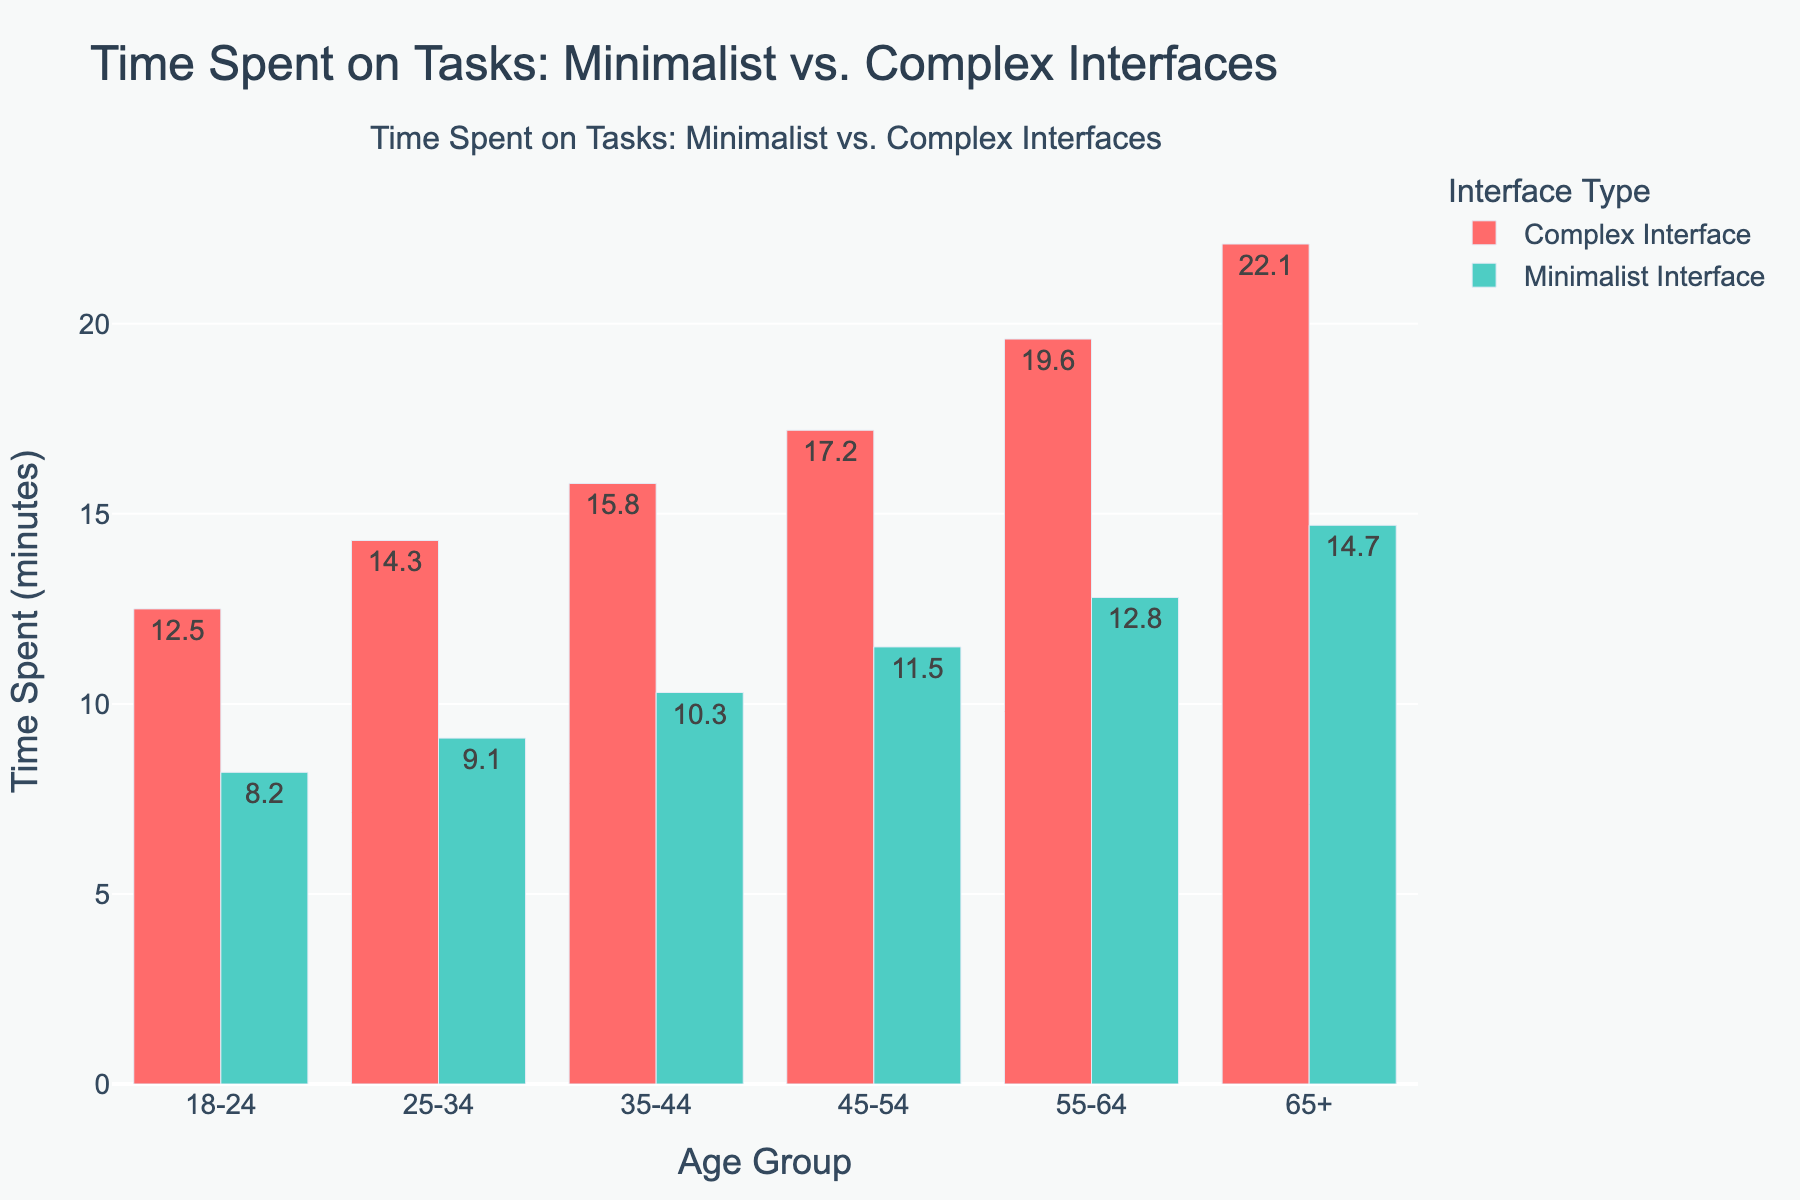What's the difference in time spent on tasks between the 25-34 age group using minimalist and complex interfaces? The time spent on tasks for the 25-34 age group using the minimalist interface is 9.1 minutes and for the complex interface, it's 14.3 minutes. The difference is 14.3 - 9.1 = 5.2 minutes.
Answer: 5.2 minutes Which age group shows the greatest difference in time spent on tasks between minimalist and complex interfaces? Inspect the differences between the minimalist and complex interface times for all age groups: 18-24 (12.5 - 8.2 = 4.3), 25-34 (14.3 - 9.1 = 5.2), 35-44 (15.8 - 10.3 = 5.5), 45-54 (17.2 - 11.5 = 5.7), 55-64 (19.6 - 12.8 = 6.8), 65+ (22.1 - 14.7 = 7.4). The age group 65+ shows the greatest difference of 7.4 minutes.
Answer: 65+ For which age group is time spent on tasks the lowest when using the complex interface? Identify the time spent on tasks for the complex interface: 18-24 (12.5), 25-34 (14.3), 35-44 (15.8), 45-54 (17.2), 55-64 (19.6), 65+ (22.1). The lowest time spent is for the 18-24 age group, which is 12.5 minutes.
Answer: 18-24 What is the average time spent on tasks across all age groups for the minimalist interface? Sum the times spent: 8.2 + 9.1 + 10.3 + 11.5 + 12.8 + 14.7 = 66.6 minutes, and divide by the number of age groups: 66.6 / 6 = 11.1 minutes.
Answer: 11.1 minutes How much more time, on average, do all age groups spend using a complex interface compared to a minimalist interface? Calculate the average for both interfaces: Complex Interface (12.5 + 14.3 + 15.8 + 17.2 + 19.6 + 22.1 = 101.5, 101.5 / 6 = 16.9). Minimalist Interface (8.2 + 9.1 + 10.3 + 11.5 + 12.8 + 14.7 = 66.6, 66.6 / 6 = 11.1). The difference: 16.9 - 11.1 = 5.8 minutes.
Answer: 5.8 minutes Which interface type shows a steeper increase in time spent on tasks with increasing age groups? Visually inspect the bars: Time spent in the complex interface increases more dramatically than in the minimalist interface across all age groups.
Answer: Complex Interface Is there any age group where the difference in time spent between the two interfaces is less than 5 minutes? Calculate differences for each age group: 18-24 (4.3), 25-34 (5.2), 35-44 (5.5), 45-54 (5.7), 55-64 (6.8), 65+ (7.4). Only the 18-24 group has a difference less than 5 minutes.
Answer: Yes, 18-24 What is the total time spent on tasks by the 35-44 age group across both interfaces? Sum the times for the 35-44 age group: 15.8 (complex) + 10.3 (minimalist) = 26.1 minutes.
Answer: 26.1 minutes Which age group shows the least difference in time spent between the complex and minimalist interfaces, aside from the 18-24 group? Compare the differences: 25-34 (5.2), 35-44 (5.5), 45-54 (5.7), 55-64 (6.8), 65+ (7.4). The 25-34 age group has the next smallest difference of 5.2 minutes.
Answer: 25-34 